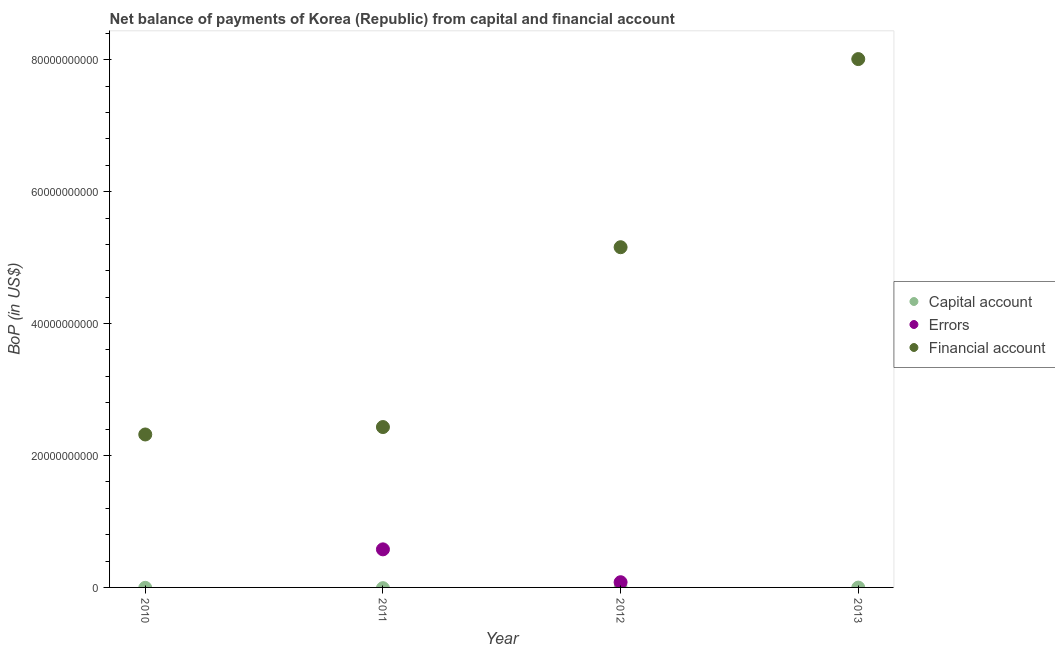How many different coloured dotlines are there?
Your response must be concise. 2. Is the number of dotlines equal to the number of legend labels?
Your answer should be very brief. No. What is the amount of errors in 2012?
Your answer should be compact. 7.89e+08. Across all years, what is the maximum amount of errors?
Ensure brevity in your answer.  5.77e+09. Across all years, what is the minimum amount of net capital account?
Provide a succinct answer. 0. What is the total amount of financial account in the graph?
Your answer should be very brief. 1.79e+11. What is the difference between the amount of financial account in 2011 and that in 2013?
Offer a terse response. -5.58e+1. What is the difference between the amount of errors in 2011 and the amount of net capital account in 2010?
Offer a terse response. 5.77e+09. What is the average amount of errors per year?
Provide a short and direct response. 1.64e+09. In the year 2011, what is the difference between the amount of errors and amount of financial account?
Offer a very short reply. -1.85e+1. In how many years, is the amount of errors greater than 40000000000 US$?
Give a very brief answer. 0. What is the ratio of the amount of financial account in 2012 to that in 2013?
Your answer should be compact. 0.64. What is the difference between the highest and the lowest amount of errors?
Provide a short and direct response. 5.77e+09. In how many years, is the amount of net capital account greater than the average amount of net capital account taken over all years?
Keep it short and to the point. 0. Is the sum of the amount of financial account in 2010 and 2011 greater than the maximum amount of net capital account across all years?
Ensure brevity in your answer.  Yes. Is it the case that in every year, the sum of the amount of net capital account and amount of errors is greater than the amount of financial account?
Your response must be concise. No. Does the amount of net capital account monotonically increase over the years?
Provide a short and direct response. No. Is the amount of financial account strictly less than the amount of errors over the years?
Your answer should be very brief. No. What is the difference between two consecutive major ticks on the Y-axis?
Ensure brevity in your answer.  2.00e+1. Does the graph contain any zero values?
Make the answer very short. Yes. How are the legend labels stacked?
Provide a succinct answer. Vertical. What is the title of the graph?
Keep it short and to the point. Net balance of payments of Korea (Republic) from capital and financial account. What is the label or title of the Y-axis?
Your answer should be very brief. BoP (in US$). What is the BoP (in US$) of Financial account in 2010?
Your response must be concise. 2.32e+1. What is the BoP (in US$) of Capital account in 2011?
Offer a very short reply. 0. What is the BoP (in US$) of Errors in 2011?
Make the answer very short. 5.77e+09. What is the BoP (in US$) of Financial account in 2011?
Your answer should be compact. 2.43e+1. What is the BoP (in US$) of Capital account in 2012?
Your answer should be compact. 0. What is the BoP (in US$) of Errors in 2012?
Your answer should be very brief. 7.89e+08. What is the BoP (in US$) in Financial account in 2012?
Keep it short and to the point. 5.16e+1. What is the BoP (in US$) in Capital account in 2013?
Your answer should be very brief. 0. What is the BoP (in US$) in Errors in 2013?
Provide a short and direct response. 0. What is the BoP (in US$) of Financial account in 2013?
Offer a very short reply. 8.01e+1. Across all years, what is the maximum BoP (in US$) in Errors?
Your response must be concise. 5.77e+09. Across all years, what is the maximum BoP (in US$) of Financial account?
Keep it short and to the point. 8.01e+1. Across all years, what is the minimum BoP (in US$) of Errors?
Make the answer very short. 0. Across all years, what is the minimum BoP (in US$) of Financial account?
Provide a succinct answer. 2.32e+1. What is the total BoP (in US$) in Errors in the graph?
Ensure brevity in your answer.  6.56e+09. What is the total BoP (in US$) of Financial account in the graph?
Your answer should be compact. 1.79e+11. What is the difference between the BoP (in US$) in Financial account in 2010 and that in 2011?
Offer a terse response. -1.13e+09. What is the difference between the BoP (in US$) of Financial account in 2010 and that in 2012?
Give a very brief answer. -2.84e+1. What is the difference between the BoP (in US$) in Financial account in 2010 and that in 2013?
Keep it short and to the point. -5.69e+1. What is the difference between the BoP (in US$) in Errors in 2011 and that in 2012?
Give a very brief answer. 4.98e+09. What is the difference between the BoP (in US$) in Financial account in 2011 and that in 2012?
Offer a terse response. -2.73e+1. What is the difference between the BoP (in US$) in Financial account in 2011 and that in 2013?
Keep it short and to the point. -5.58e+1. What is the difference between the BoP (in US$) in Financial account in 2012 and that in 2013?
Your response must be concise. -2.85e+1. What is the difference between the BoP (in US$) of Errors in 2011 and the BoP (in US$) of Financial account in 2012?
Your answer should be very brief. -4.58e+1. What is the difference between the BoP (in US$) in Errors in 2011 and the BoP (in US$) in Financial account in 2013?
Ensure brevity in your answer.  -7.43e+1. What is the difference between the BoP (in US$) in Errors in 2012 and the BoP (in US$) in Financial account in 2013?
Give a very brief answer. -7.93e+1. What is the average BoP (in US$) of Capital account per year?
Your response must be concise. 0. What is the average BoP (in US$) of Errors per year?
Give a very brief answer. 1.64e+09. What is the average BoP (in US$) in Financial account per year?
Give a very brief answer. 4.48e+1. In the year 2011, what is the difference between the BoP (in US$) in Errors and BoP (in US$) in Financial account?
Give a very brief answer. -1.85e+1. In the year 2012, what is the difference between the BoP (in US$) of Errors and BoP (in US$) of Financial account?
Your answer should be compact. -5.08e+1. What is the ratio of the BoP (in US$) in Financial account in 2010 to that in 2011?
Provide a short and direct response. 0.95. What is the ratio of the BoP (in US$) in Financial account in 2010 to that in 2012?
Make the answer very short. 0.45. What is the ratio of the BoP (in US$) in Financial account in 2010 to that in 2013?
Give a very brief answer. 0.29. What is the ratio of the BoP (in US$) in Errors in 2011 to that in 2012?
Provide a succinct answer. 7.31. What is the ratio of the BoP (in US$) of Financial account in 2011 to that in 2012?
Ensure brevity in your answer.  0.47. What is the ratio of the BoP (in US$) in Financial account in 2011 to that in 2013?
Provide a succinct answer. 0.3. What is the ratio of the BoP (in US$) in Financial account in 2012 to that in 2013?
Make the answer very short. 0.64. What is the difference between the highest and the second highest BoP (in US$) in Financial account?
Your response must be concise. 2.85e+1. What is the difference between the highest and the lowest BoP (in US$) in Errors?
Your answer should be compact. 5.77e+09. What is the difference between the highest and the lowest BoP (in US$) of Financial account?
Ensure brevity in your answer.  5.69e+1. 